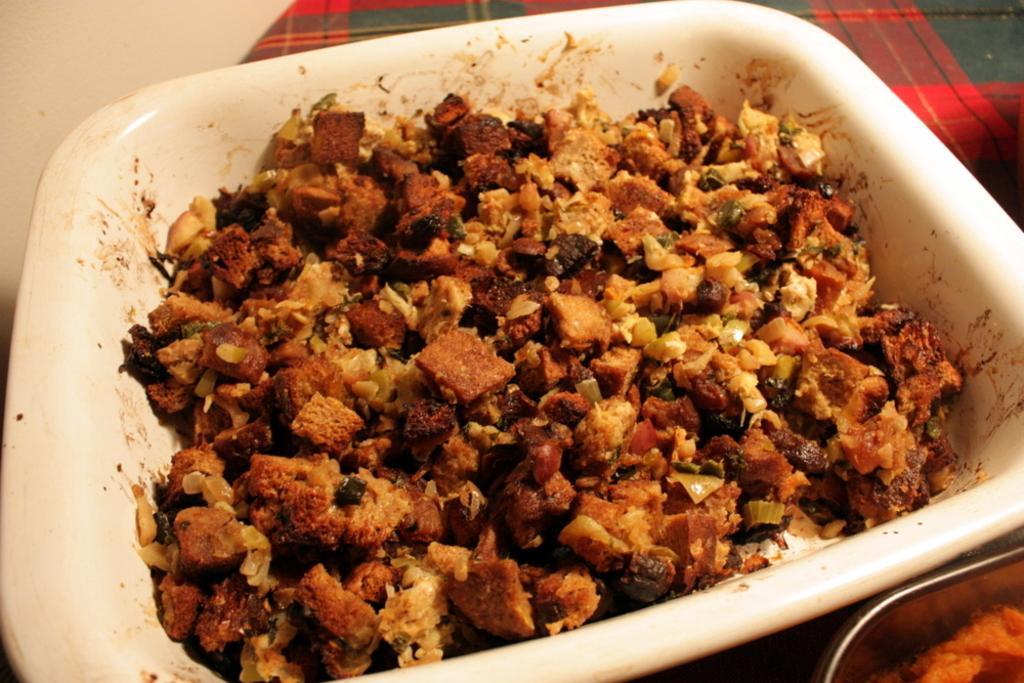How would you summarize this image in a sentence or two? In the center of this picture we can see a white color palette containing some food items. On the right we can see a cloth and some other objects. 